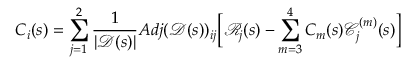Convert formula to latex. <formula><loc_0><loc_0><loc_500><loc_500>C _ { i } ( s ) = \sum _ { j = 1 } ^ { 2 } \frac { 1 } { | \ m a t h s c r { D } ( s ) | } A d j ( \ m a t h s c r { D } ( s ) ) _ { i j } \left [ \ m a t h s c r { R } _ { j } ( s ) - \sum _ { m = 3 } ^ { 4 } C _ { m } ( s ) \ m a t h s c r { C } _ { j } ^ { ( m ) } ( s ) \right ]</formula> 